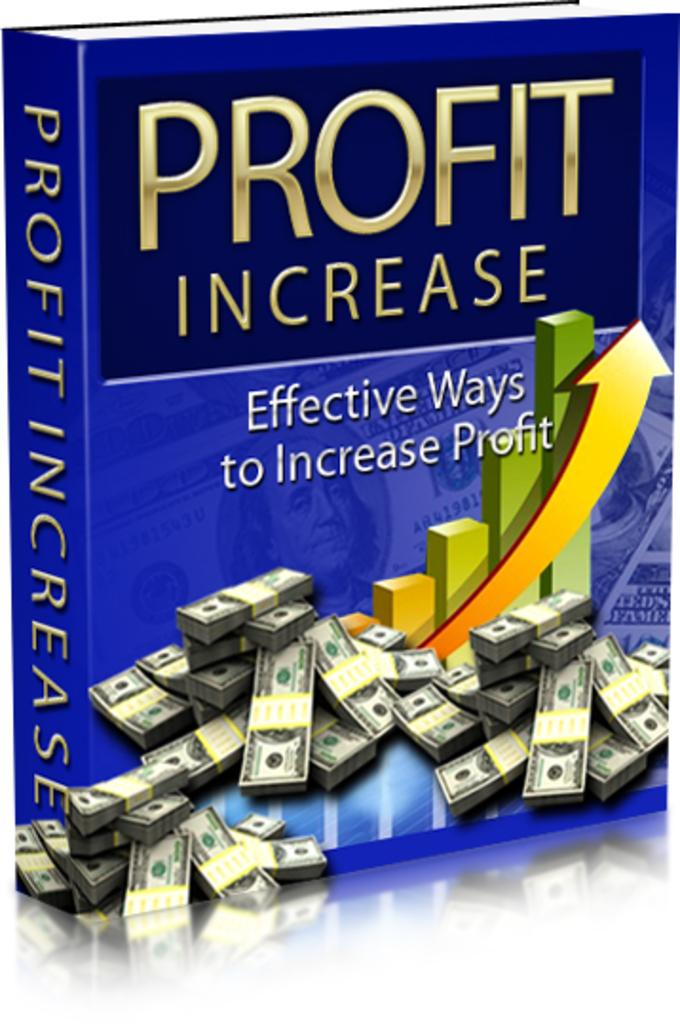<image>
Give a short and clear explanation of the subsequent image. A blue book cover for "Profit Increase" has yellow arrows. 